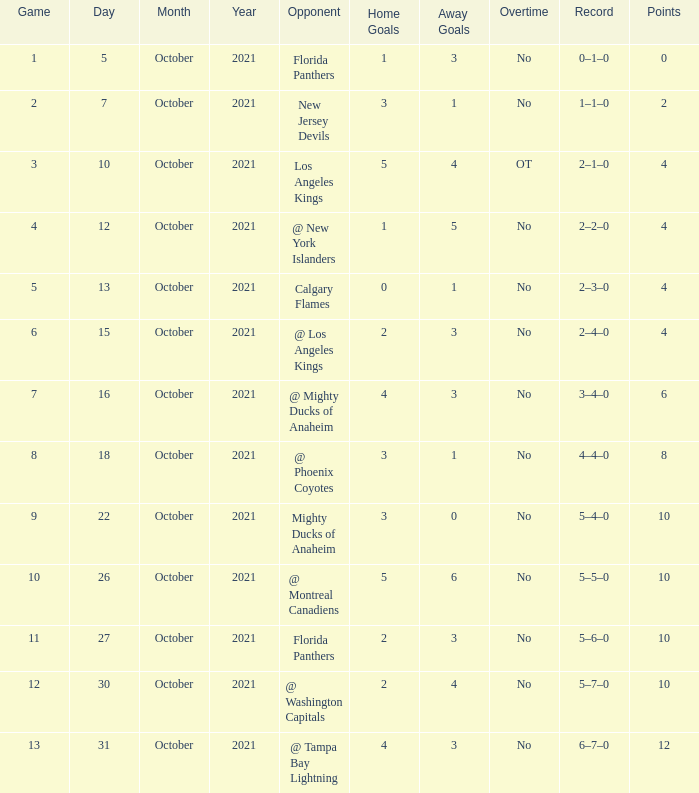What team has a score of 11 5–6–0. 